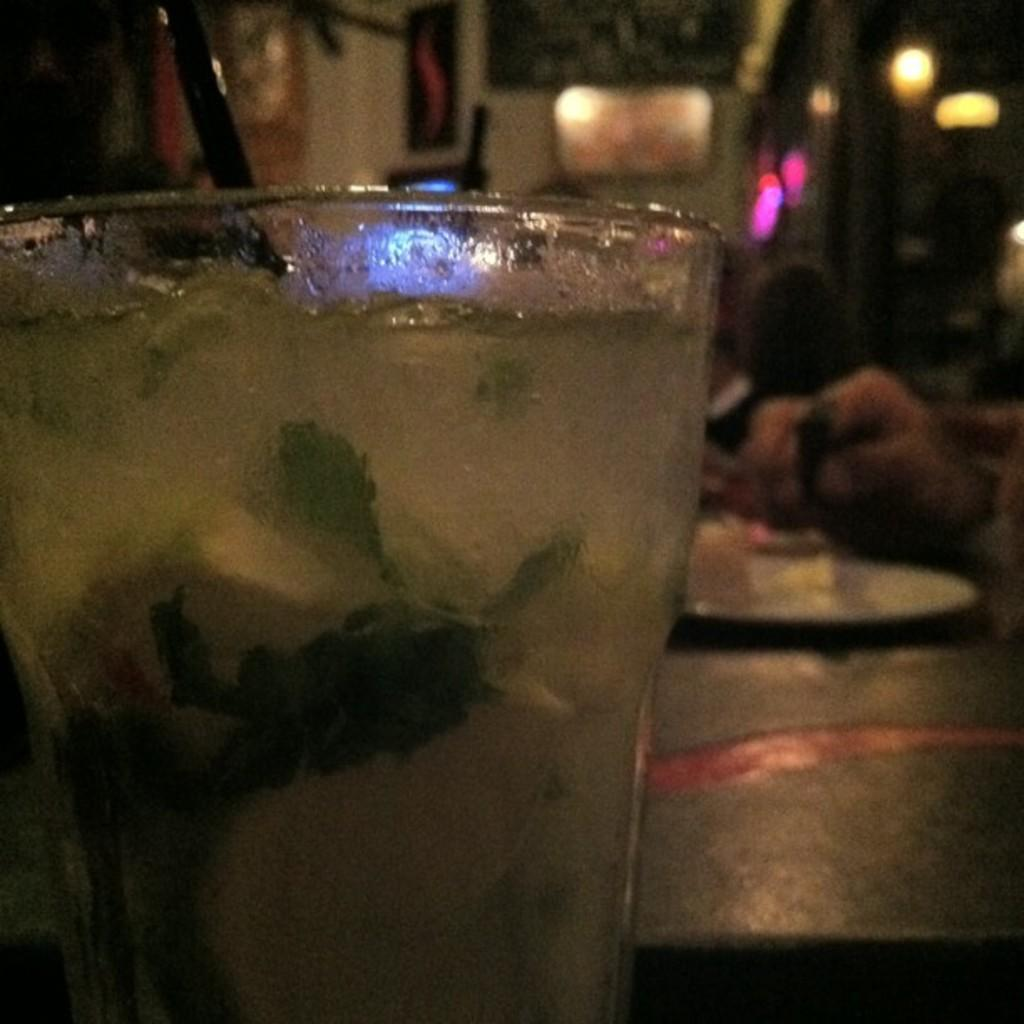What is contained in the glass that is visible in the image? There is a glass with liquid in the image. What is present on the table in the image? There is a plate on the table in the image. What part of a person can be seen in the image? A human hand is visible in the image. What type of illumination is present in the image? There are lights in the image. How would you describe the background of the image? The background of the image is blurry. What type of pest can be seen crawling on the plate in the image? There is no pest present on the plate in the image; it only contains a plate. What form of entertainment is being played in the image? There is no game or form of entertainment present in the image. 